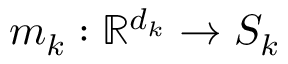Convert formula to latex. <formula><loc_0><loc_0><loc_500><loc_500>m _ { k } \colon \mathbb { R } ^ { d _ { k } } \rightarrow S _ { k }</formula> 